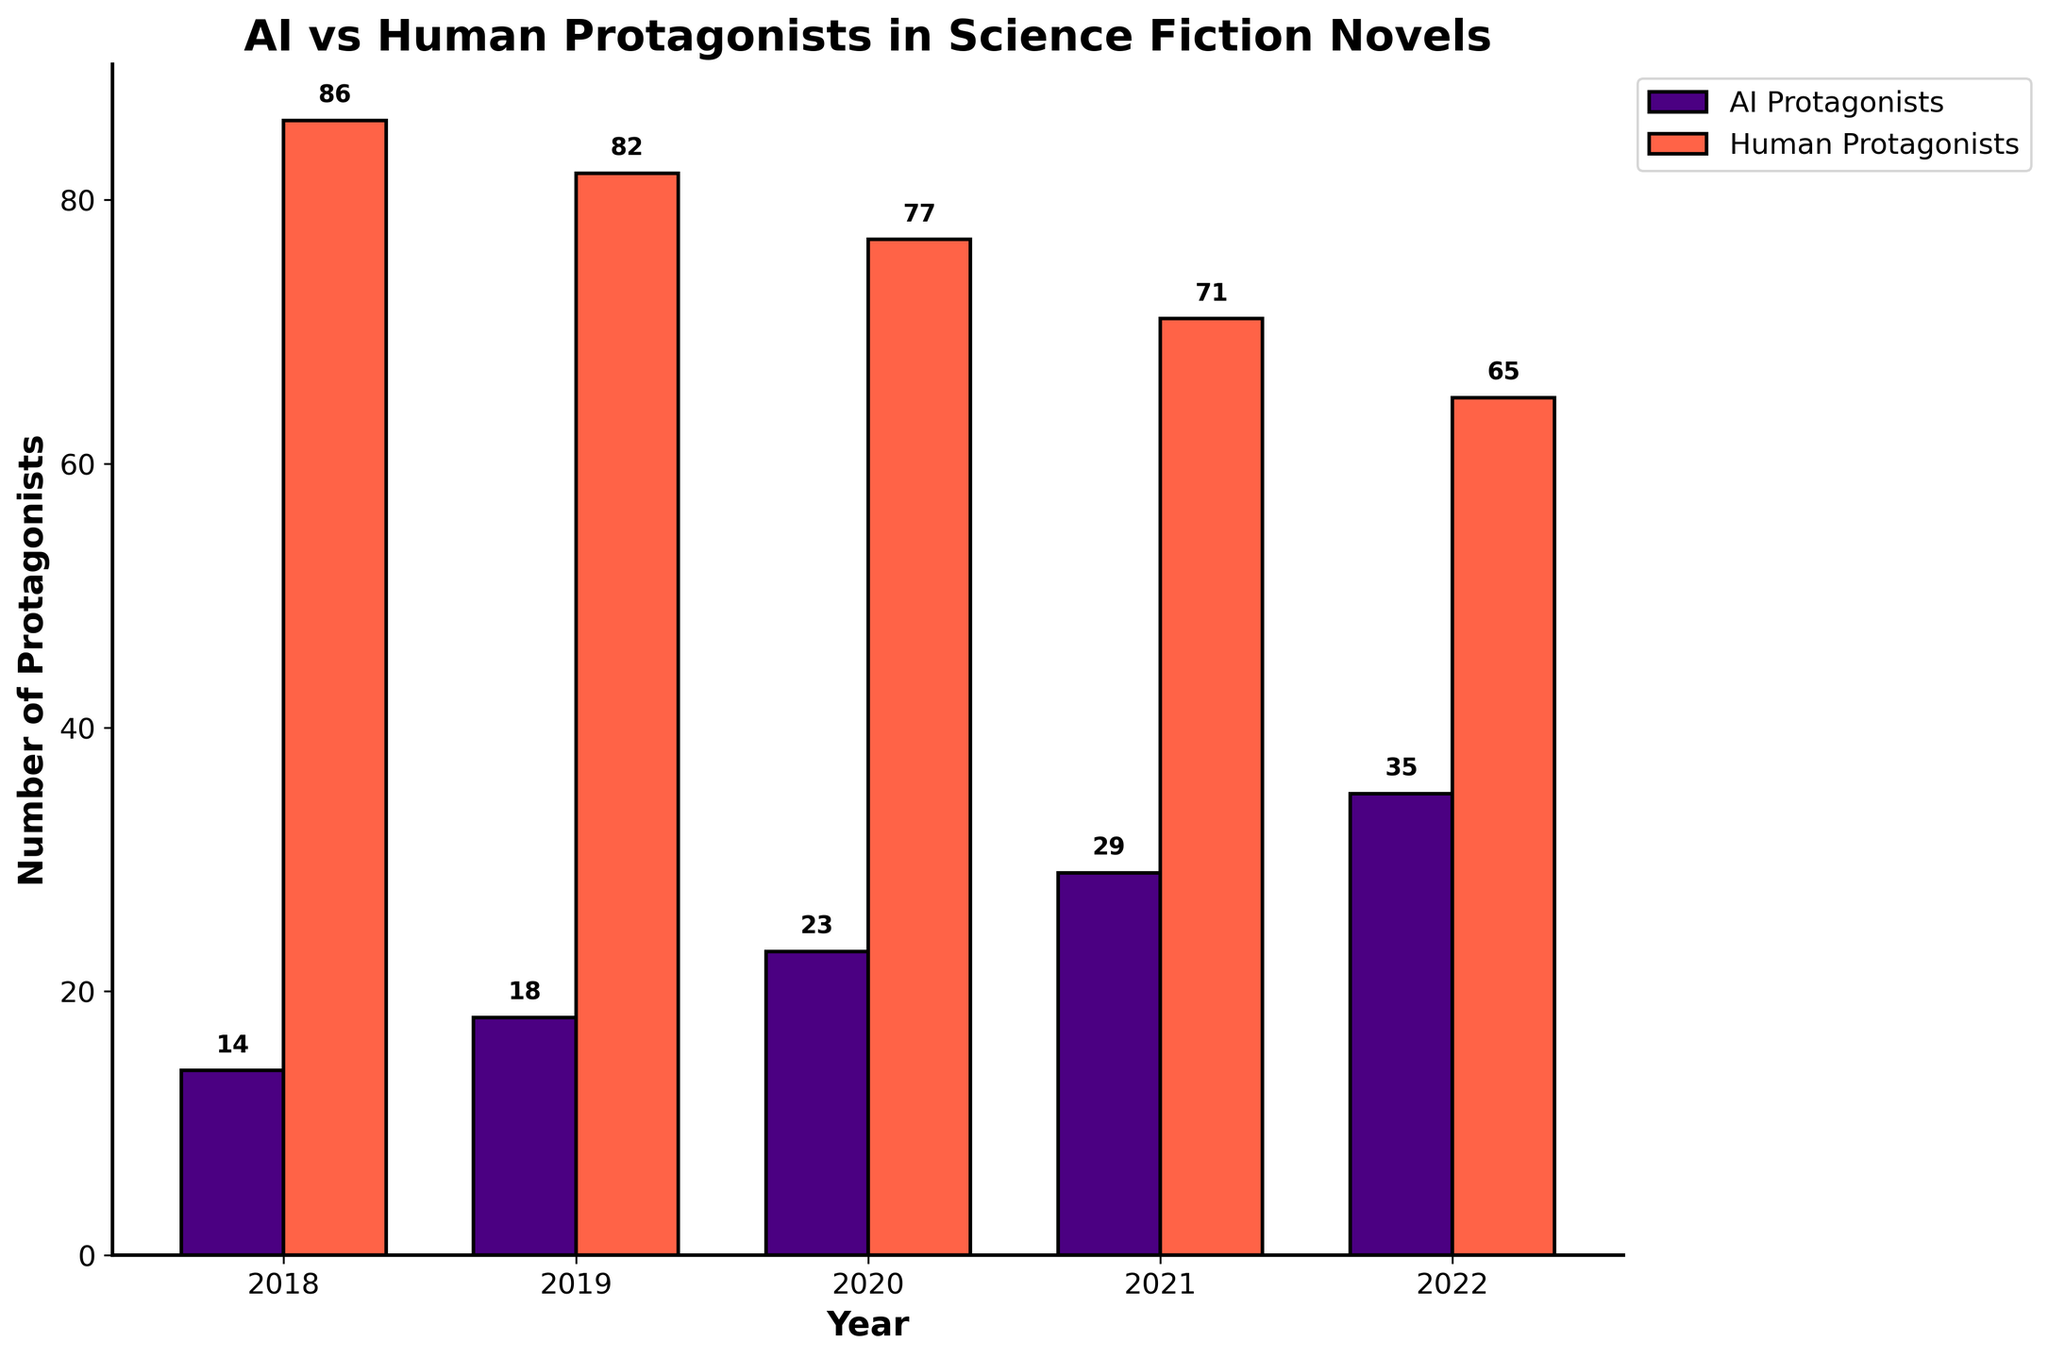What is the overall trend for AI protagonists from 2018 to 2022? The trend for AI protagonists is determined by looking at the height of the purple bars across the years. The height of the bars increases each year, indicating an upward trend in AI protagonists from 14 in 2018 to 35 in 2022.
Answer: The number of AI protagonists has been increasing How many more human protagonists were there compared to AI protagonists in 2018? Subtract the number of AI protagonists in 2018 from the number of human protagonists in 2018 (86 - 14 = 72).
Answer: 72 In which year did the number of AI protagonists first exceed 20? Look at the purple bars to find the first year where the AI protagonists bar exceeds the height corresponding to 20. This occurs in 2020, where the number of AI protagonists is 23.
Answer: 2020 What is the average number of AI protagonists from 2018 to 2022? Add the numbers of AI protagonists for each year (14 + 18 + 23 + 29 + 35 = 119) and then divide by the number of years (119 / 5 = 23.8).
Answer: 23.8 Which category of protagonists showed the least change in numbers over the five years? Compare the increase in the number of AI and human protagonists from 2018 to 2022. AI protagonists increased by 21 (35-14), and human protagonists decreased by 21 (86-65). Since the changes are of equal magnitude but opposite direction, both categories changed equally.
Answer: Both categories showed equal change By how much did the number of human protagonists decrease from 2018 to 2022? Subtract the number of human protagonists in 2022 from the number in 2018 (86 - 65 = 21).
Answer: 21 